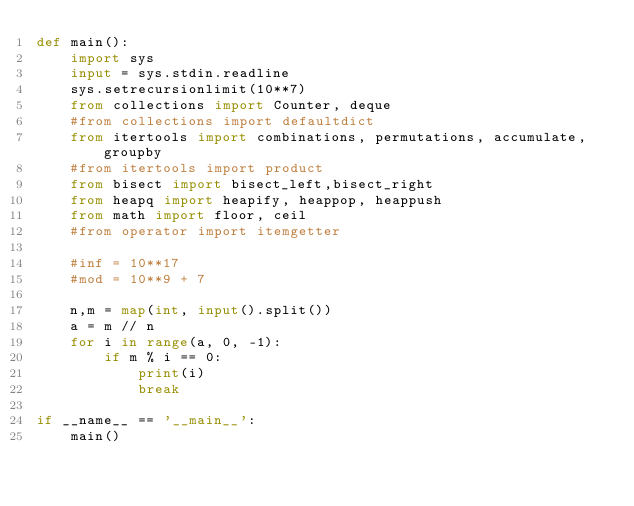Convert code to text. <code><loc_0><loc_0><loc_500><loc_500><_Python_>def main():
    import sys
    input = sys.stdin.readline
    sys.setrecursionlimit(10**7)
    from collections import Counter, deque
    #from collections import defaultdict
    from itertools import combinations, permutations, accumulate, groupby
    #from itertools import product
    from bisect import bisect_left,bisect_right
    from heapq import heapify, heappop, heappush
    from math import floor, ceil
    #from operator import itemgetter

    #inf = 10**17
    #mod = 10**9 + 7

    n,m = map(int, input().split())
    a = m // n
    for i in range(a, 0, -1):
        if m % i == 0:
            print(i)
            break

if __name__ == '__main__':
    main()</code> 